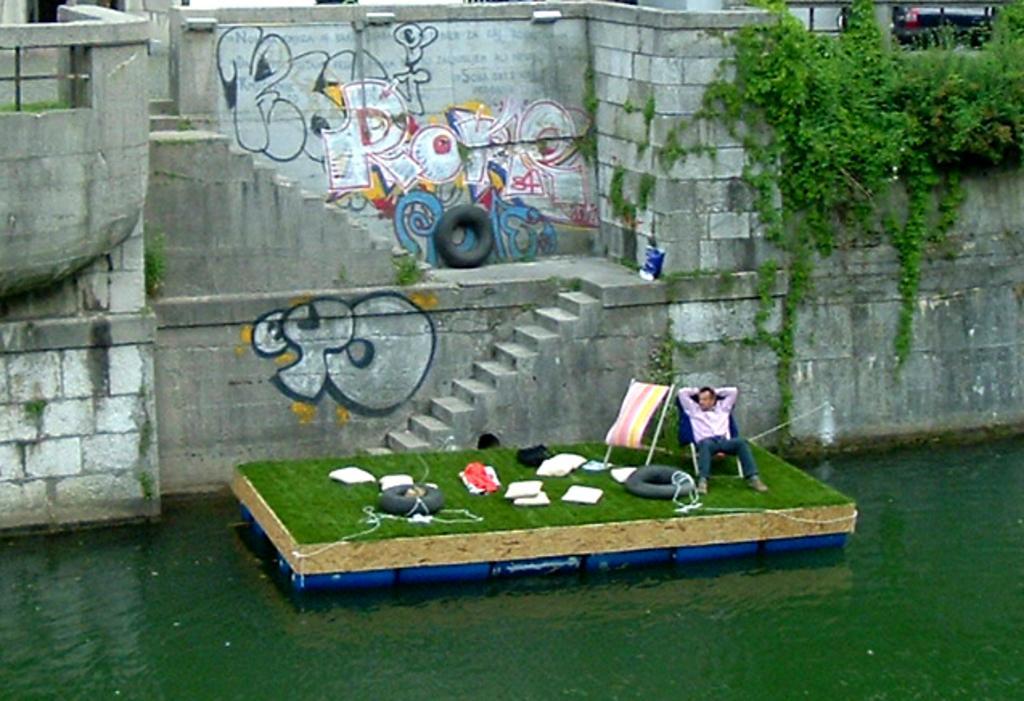In one or two sentences, can you explain what this image depicts? In this image there is one person sitting on the chair is on the boat as we can see in the bottom of this image. There is a lake in the bottom of this image. There is a wall on the top of this image. There is a Tyre is kept in the middle of this image. There are some plants on the right side of this image. 